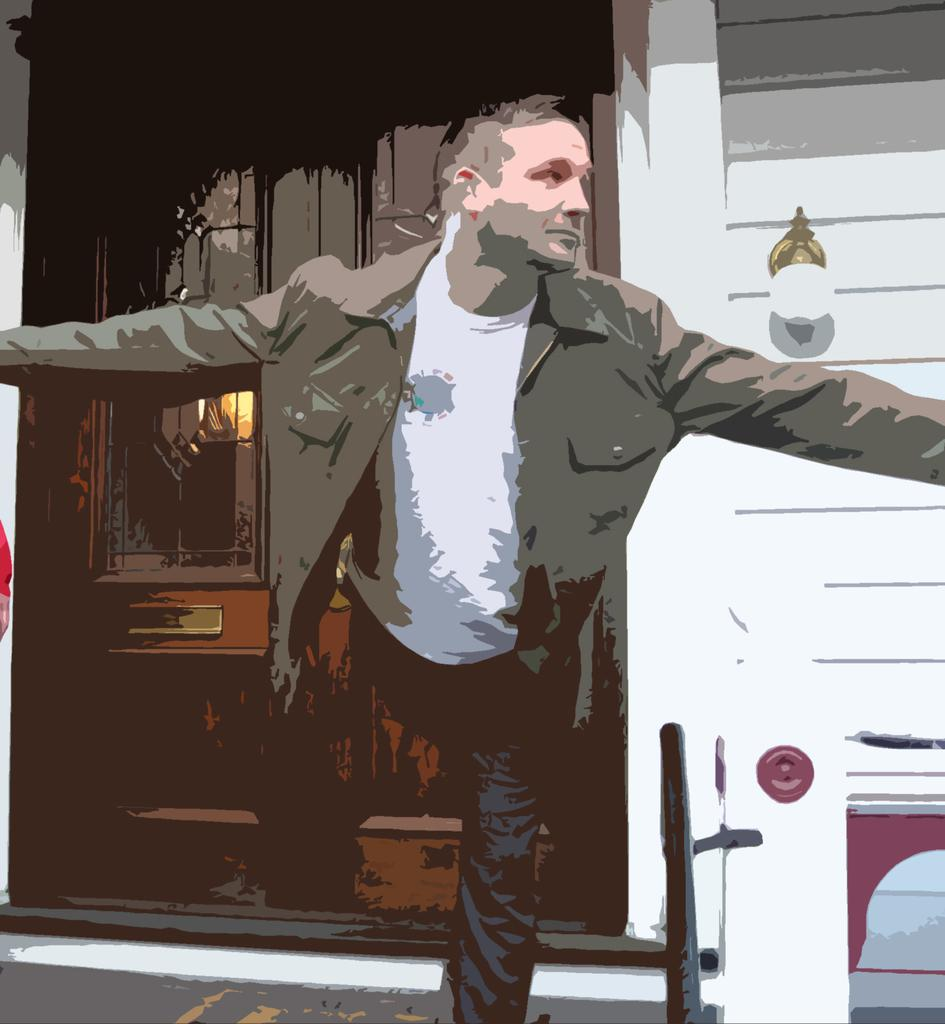What is the person in the image wearing? The person in the image is wearing a white t-shirt. What can be seen on the wall in the image? There is a light on the wall in the image. What architectural feature is visible in the image? There is a door visible in the image. How many mice are visible in the image? There are no mice present in the image. What type of wound is being treated by the person in the image? There is no wound visible in the image, nor is there any indication that the person is treating a wound. 